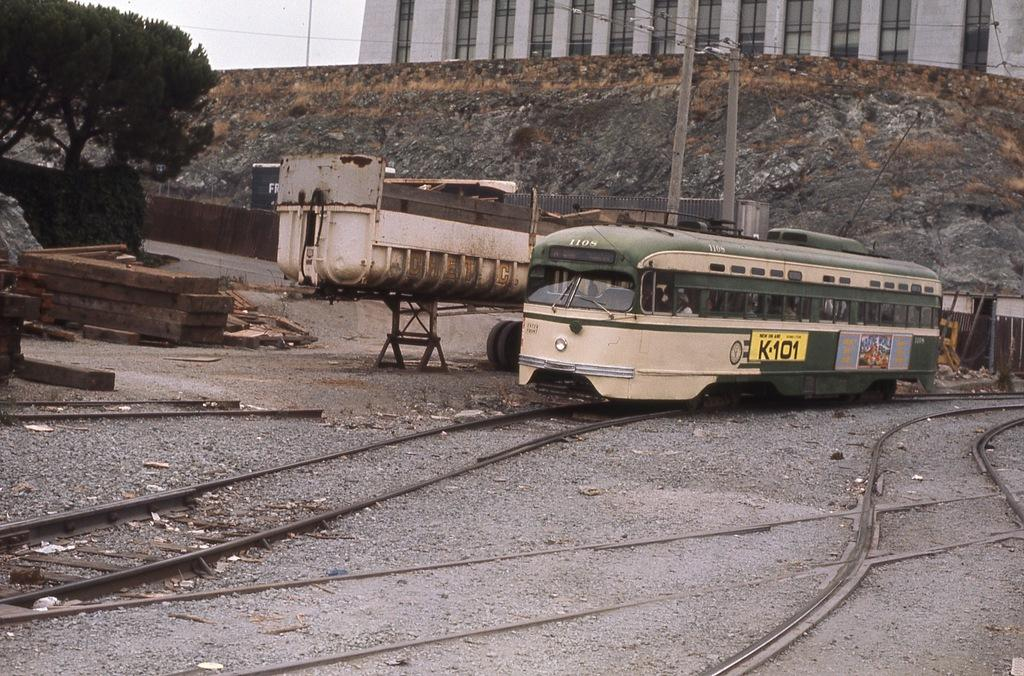<image>
Give a short and clear explanation of the subsequent image. a train with k 101 on the side of it 